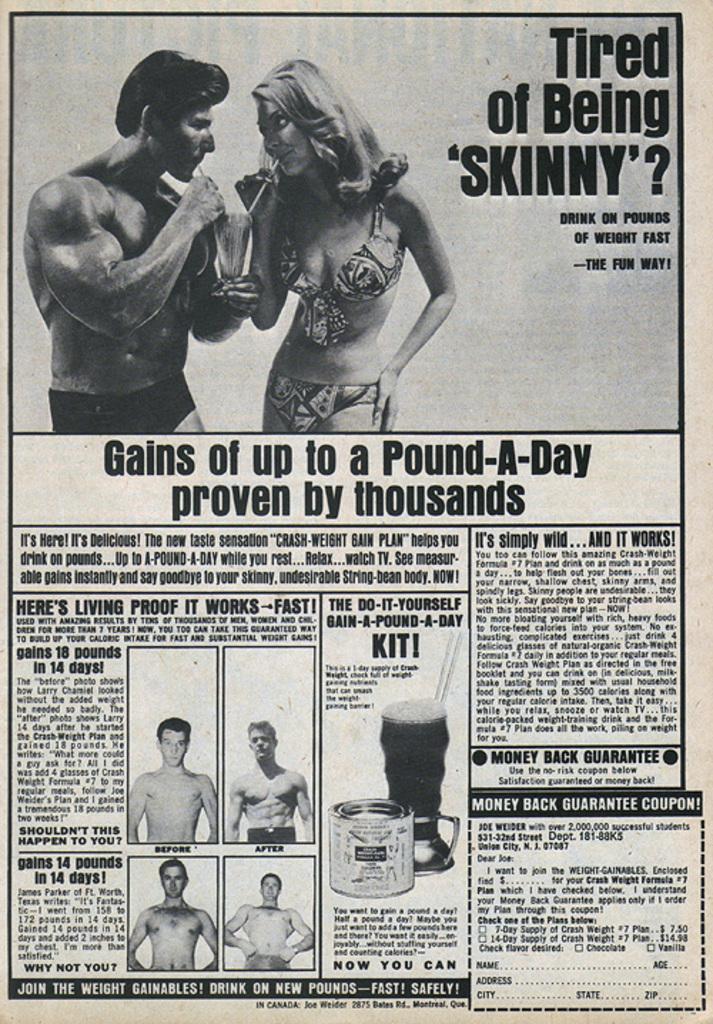Please provide a concise description of this image. In this image I can see a news paper , on the newspaper I can see person images and text. 